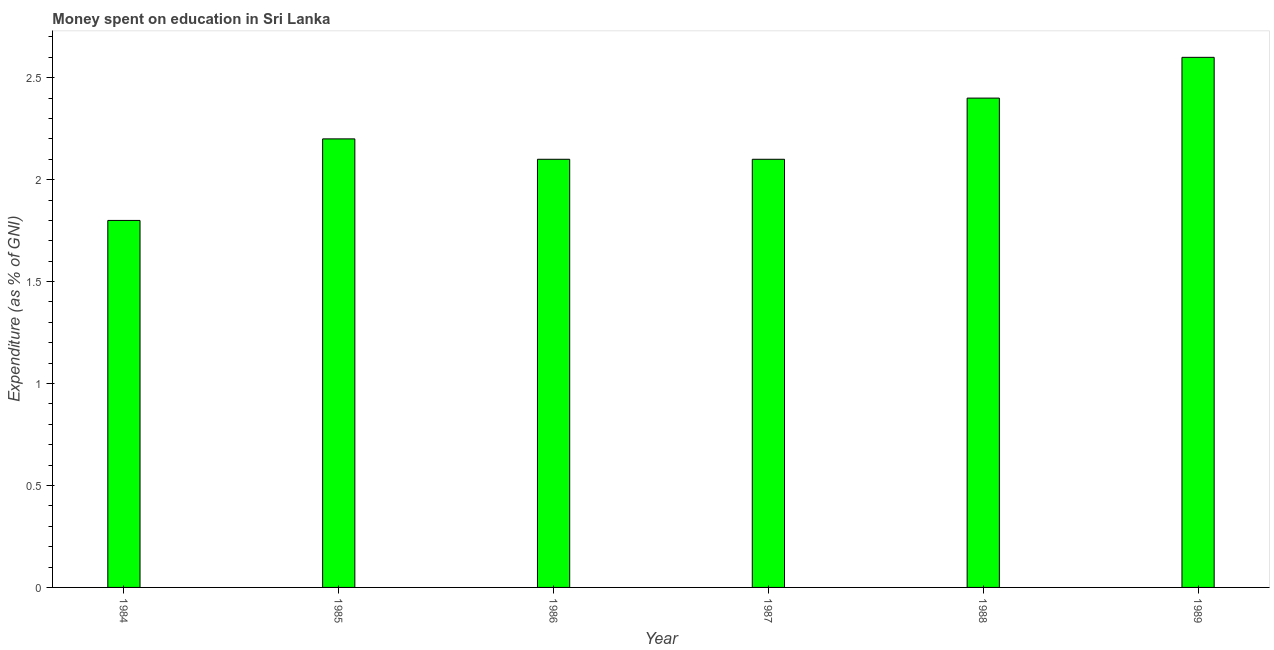Does the graph contain grids?
Your response must be concise. No. What is the title of the graph?
Your response must be concise. Money spent on education in Sri Lanka. What is the label or title of the X-axis?
Provide a short and direct response. Year. What is the label or title of the Y-axis?
Offer a terse response. Expenditure (as % of GNI). What is the expenditure on education in 1988?
Make the answer very short. 2.4. Across all years, what is the maximum expenditure on education?
Offer a very short reply. 2.6. Across all years, what is the minimum expenditure on education?
Your answer should be very brief. 1.8. In which year was the expenditure on education maximum?
Give a very brief answer. 1989. In which year was the expenditure on education minimum?
Provide a short and direct response. 1984. What is the sum of the expenditure on education?
Give a very brief answer. 13.2. What is the difference between the expenditure on education in 1984 and 1989?
Offer a terse response. -0.8. What is the median expenditure on education?
Your answer should be compact. 2.15. In how many years, is the expenditure on education greater than 2.2 %?
Make the answer very short. 2. Is the expenditure on education in 1986 less than that in 1987?
Provide a short and direct response. No. What is the difference between the highest and the second highest expenditure on education?
Give a very brief answer. 0.2. Is the sum of the expenditure on education in 1985 and 1988 greater than the maximum expenditure on education across all years?
Offer a very short reply. Yes. What is the difference between the highest and the lowest expenditure on education?
Ensure brevity in your answer.  0.8. How many bars are there?
Offer a very short reply. 6. Are the values on the major ticks of Y-axis written in scientific E-notation?
Provide a succinct answer. No. What is the Expenditure (as % of GNI) in 1984?
Give a very brief answer. 1.8. What is the Expenditure (as % of GNI) of 1985?
Offer a very short reply. 2.2. What is the Expenditure (as % of GNI) of 1987?
Provide a succinct answer. 2.1. What is the Expenditure (as % of GNI) in 1988?
Provide a short and direct response. 2.4. What is the difference between the Expenditure (as % of GNI) in 1984 and 1986?
Keep it short and to the point. -0.3. What is the difference between the Expenditure (as % of GNI) in 1984 and 1987?
Offer a very short reply. -0.3. What is the difference between the Expenditure (as % of GNI) in 1984 and 1989?
Make the answer very short. -0.8. What is the difference between the Expenditure (as % of GNI) in 1986 and 1987?
Offer a very short reply. 0. What is the difference between the Expenditure (as % of GNI) in 1987 and 1988?
Offer a very short reply. -0.3. What is the difference between the Expenditure (as % of GNI) in 1988 and 1989?
Offer a terse response. -0.2. What is the ratio of the Expenditure (as % of GNI) in 1984 to that in 1985?
Give a very brief answer. 0.82. What is the ratio of the Expenditure (as % of GNI) in 1984 to that in 1986?
Give a very brief answer. 0.86. What is the ratio of the Expenditure (as % of GNI) in 1984 to that in 1987?
Keep it short and to the point. 0.86. What is the ratio of the Expenditure (as % of GNI) in 1984 to that in 1988?
Offer a very short reply. 0.75. What is the ratio of the Expenditure (as % of GNI) in 1984 to that in 1989?
Give a very brief answer. 0.69. What is the ratio of the Expenditure (as % of GNI) in 1985 to that in 1986?
Ensure brevity in your answer.  1.05. What is the ratio of the Expenditure (as % of GNI) in 1985 to that in 1987?
Make the answer very short. 1.05. What is the ratio of the Expenditure (as % of GNI) in 1985 to that in 1988?
Your response must be concise. 0.92. What is the ratio of the Expenditure (as % of GNI) in 1985 to that in 1989?
Offer a terse response. 0.85. What is the ratio of the Expenditure (as % of GNI) in 1986 to that in 1987?
Offer a very short reply. 1. What is the ratio of the Expenditure (as % of GNI) in 1986 to that in 1989?
Your answer should be compact. 0.81. What is the ratio of the Expenditure (as % of GNI) in 1987 to that in 1988?
Keep it short and to the point. 0.88. What is the ratio of the Expenditure (as % of GNI) in 1987 to that in 1989?
Give a very brief answer. 0.81. What is the ratio of the Expenditure (as % of GNI) in 1988 to that in 1989?
Make the answer very short. 0.92. 